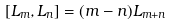Convert formula to latex. <formula><loc_0><loc_0><loc_500><loc_500>[ L _ { m } , L _ { n } ] = ( m - n ) L _ { m + n }</formula> 